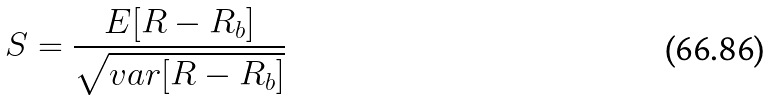Convert formula to latex. <formula><loc_0><loc_0><loc_500><loc_500>S = \frac { E [ R - R _ { b } ] } { \sqrt { v a r [ R - R _ { b } ] } }</formula> 